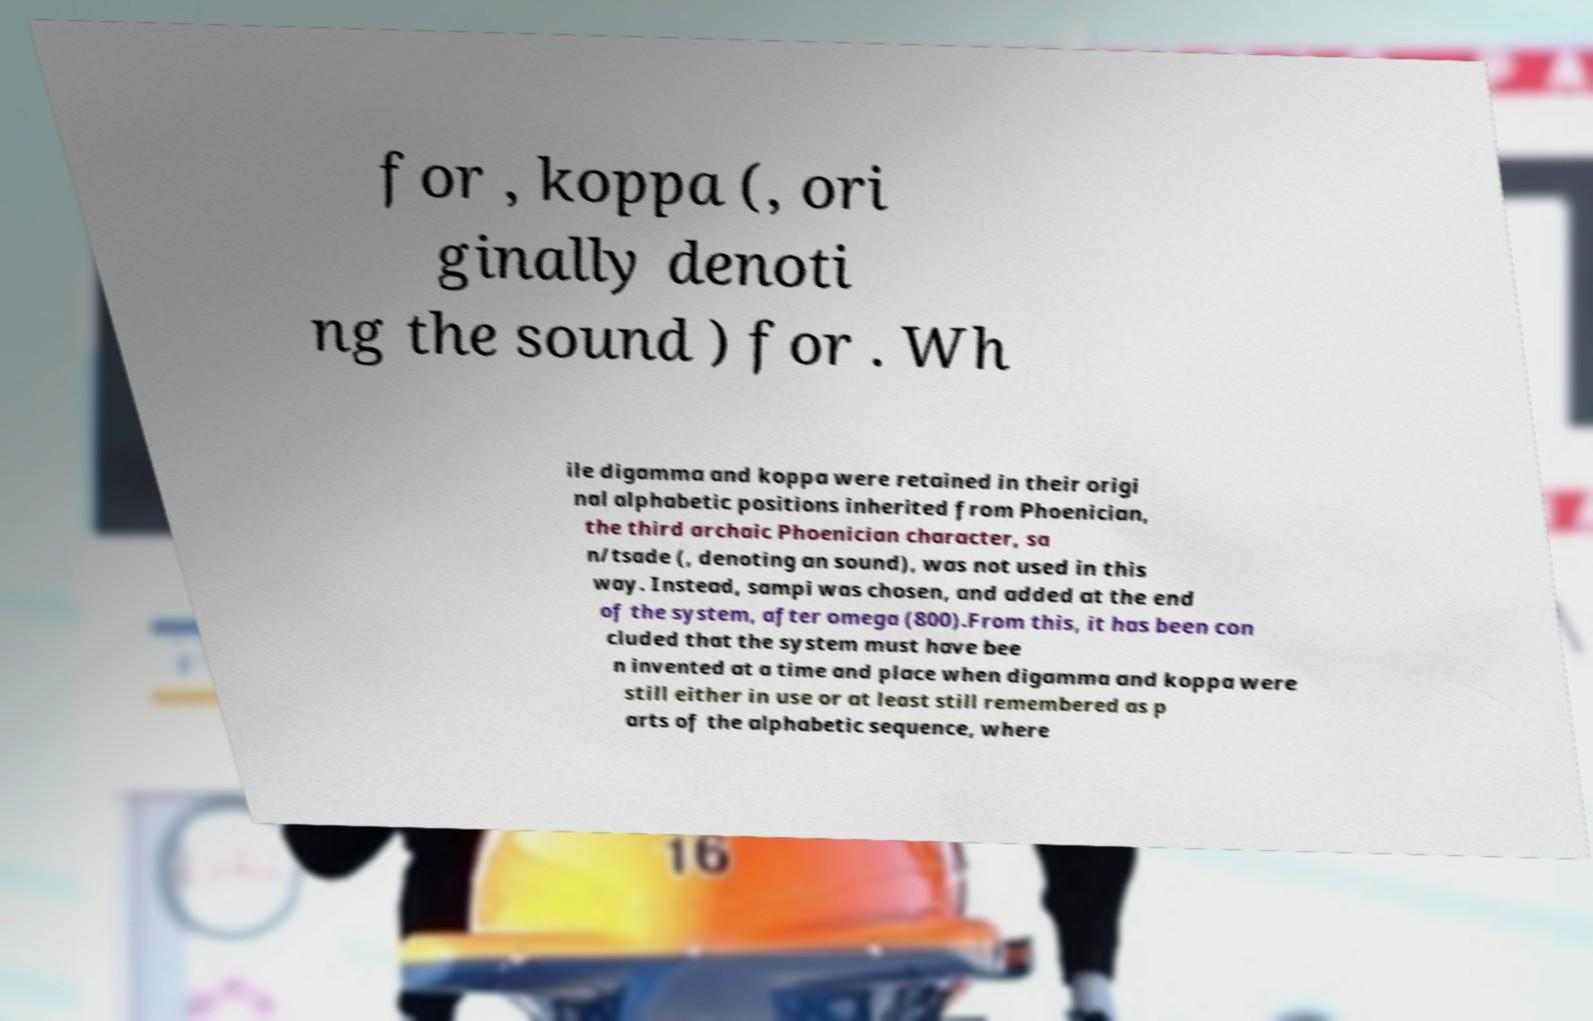Please identify and transcribe the text found in this image. for , koppa (, ori ginally denoti ng the sound ) for . Wh ile digamma and koppa were retained in their origi nal alphabetic positions inherited from Phoenician, the third archaic Phoenician character, sa n/tsade (, denoting an sound), was not used in this way. Instead, sampi was chosen, and added at the end of the system, after omega (800).From this, it has been con cluded that the system must have bee n invented at a time and place when digamma and koppa were still either in use or at least still remembered as p arts of the alphabetic sequence, where 